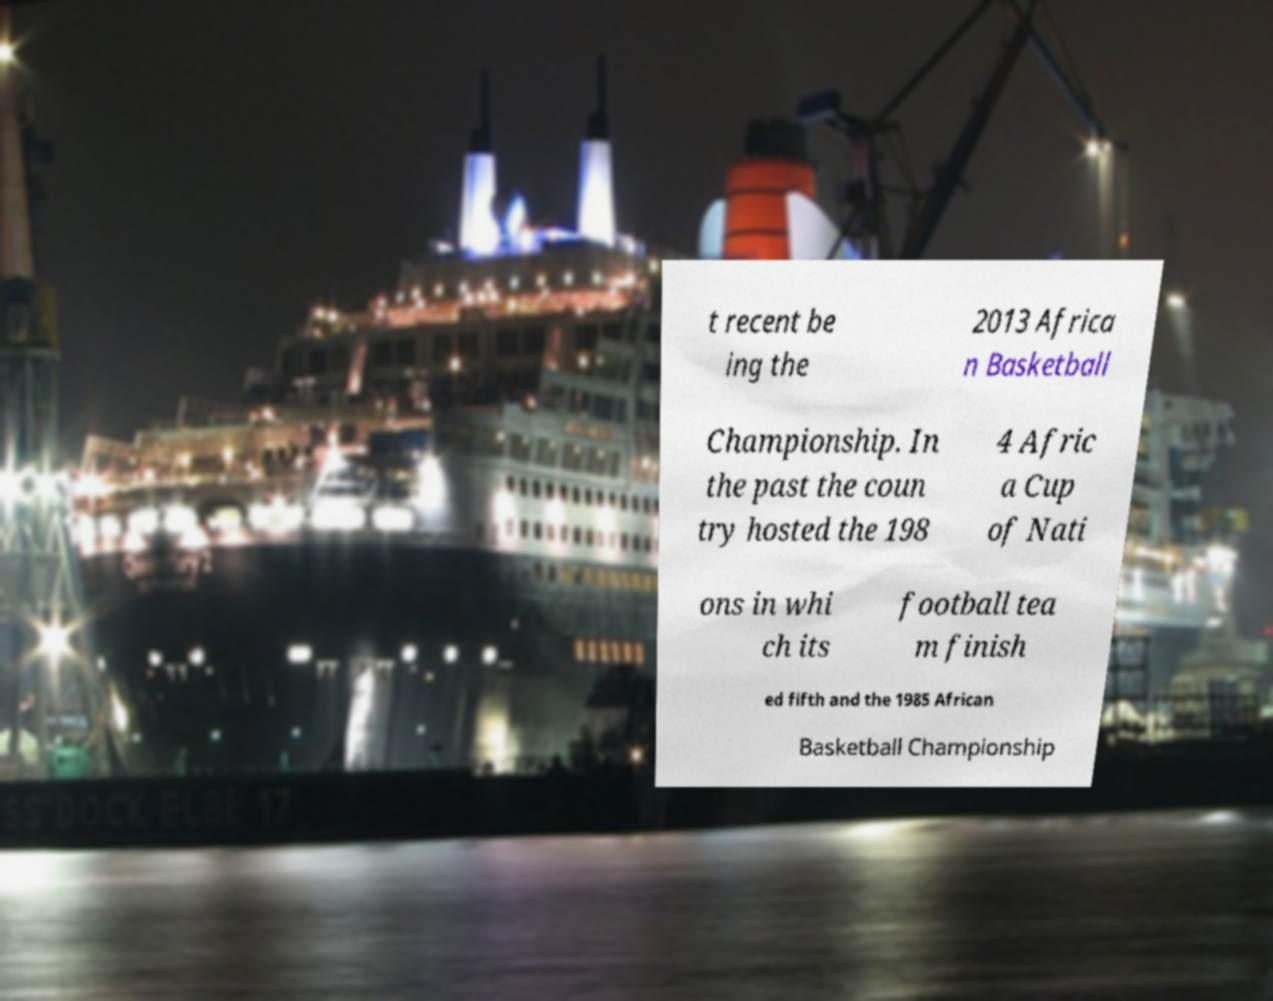Can you accurately transcribe the text from the provided image for me? t recent be ing the 2013 Africa n Basketball Championship. In the past the coun try hosted the 198 4 Afric a Cup of Nati ons in whi ch its football tea m finish ed fifth and the 1985 African Basketball Championship 